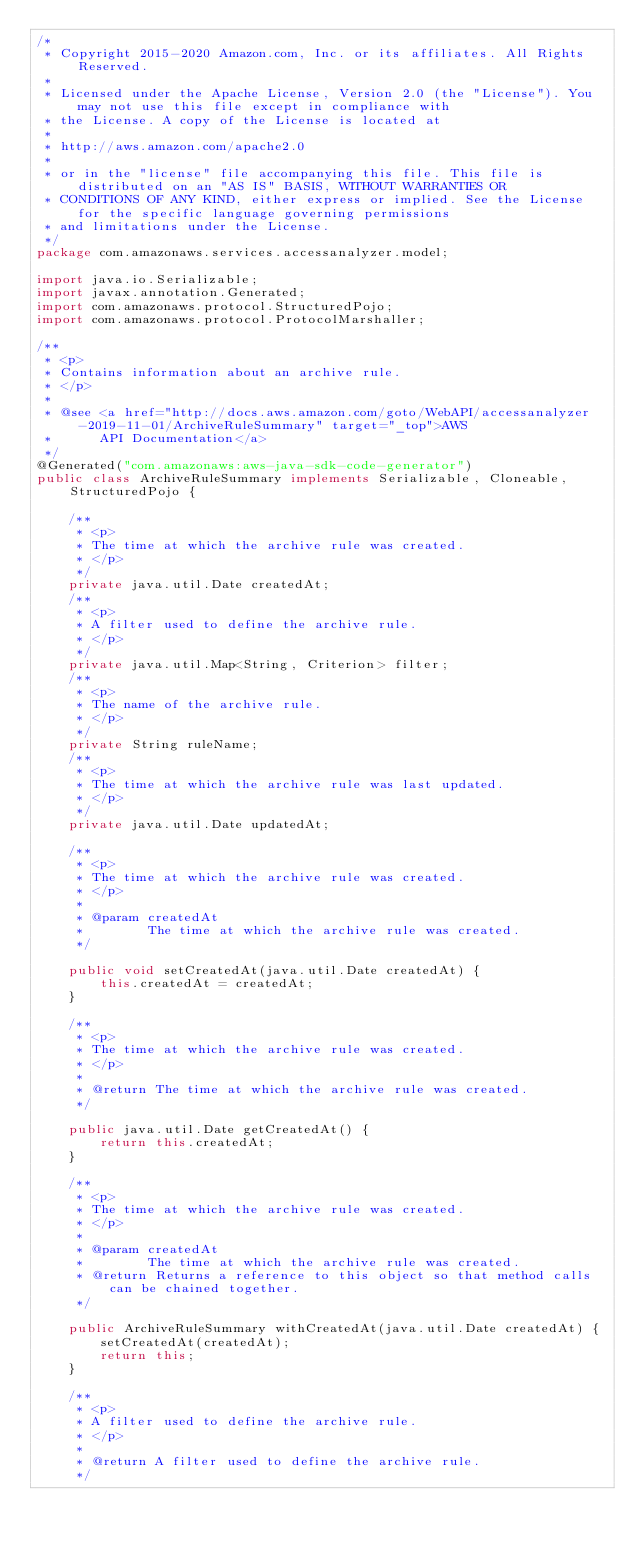<code> <loc_0><loc_0><loc_500><loc_500><_Java_>/*
 * Copyright 2015-2020 Amazon.com, Inc. or its affiliates. All Rights Reserved.
 * 
 * Licensed under the Apache License, Version 2.0 (the "License"). You may not use this file except in compliance with
 * the License. A copy of the License is located at
 * 
 * http://aws.amazon.com/apache2.0
 * 
 * or in the "license" file accompanying this file. This file is distributed on an "AS IS" BASIS, WITHOUT WARRANTIES OR
 * CONDITIONS OF ANY KIND, either express or implied. See the License for the specific language governing permissions
 * and limitations under the License.
 */
package com.amazonaws.services.accessanalyzer.model;

import java.io.Serializable;
import javax.annotation.Generated;
import com.amazonaws.protocol.StructuredPojo;
import com.amazonaws.protocol.ProtocolMarshaller;

/**
 * <p>
 * Contains information about an archive rule.
 * </p>
 * 
 * @see <a href="http://docs.aws.amazon.com/goto/WebAPI/accessanalyzer-2019-11-01/ArchiveRuleSummary" target="_top">AWS
 *      API Documentation</a>
 */
@Generated("com.amazonaws:aws-java-sdk-code-generator")
public class ArchiveRuleSummary implements Serializable, Cloneable, StructuredPojo {

    /**
     * <p>
     * The time at which the archive rule was created.
     * </p>
     */
    private java.util.Date createdAt;
    /**
     * <p>
     * A filter used to define the archive rule.
     * </p>
     */
    private java.util.Map<String, Criterion> filter;
    /**
     * <p>
     * The name of the archive rule.
     * </p>
     */
    private String ruleName;
    /**
     * <p>
     * The time at which the archive rule was last updated.
     * </p>
     */
    private java.util.Date updatedAt;

    /**
     * <p>
     * The time at which the archive rule was created.
     * </p>
     * 
     * @param createdAt
     *        The time at which the archive rule was created.
     */

    public void setCreatedAt(java.util.Date createdAt) {
        this.createdAt = createdAt;
    }

    /**
     * <p>
     * The time at which the archive rule was created.
     * </p>
     * 
     * @return The time at which the archive rule was created.
     */

    public java.util.Date getCreatedAt() {
        return this.createdAt;
    }

    /**
     * <p>
     * The time at which the archive rule was created.
     * </p>
     * 
     * @param createdAt
     *        The time at which the archive rule was created.
     * @return Returns a reference to this object so that method calls can be chained together.
     */

    public ArchiveRuleSummary withCreatedAt(java.util.Date createdAt) {
        setCreatedAt(createdAt);
        return this;
    }

    /**
     * <p>
     * A filter used to define the archive rule.
     * </p>
     * 
     * @return A filter used to define the archive rule.
     */
</code> 